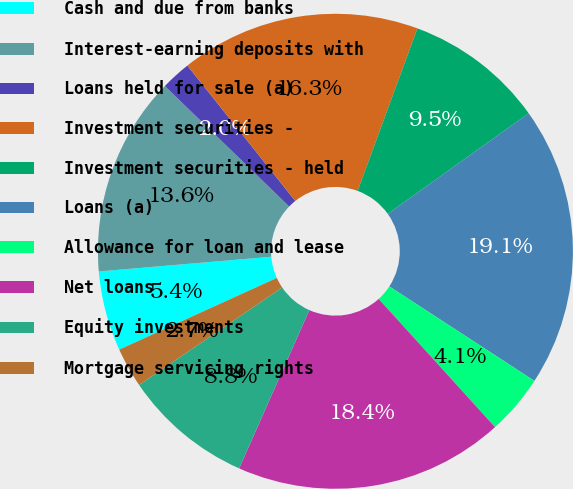<chart> <loc_0><loc_0><loc_500><loc_500><pie_chart><fcel>Cash and due from banks<fcel>Interest-earning deposits with<fcel>Loans held for sale (a)<fcel>Investment securities -<fcel>Investment securities - held<fcel>Loans (a)<fcel>Allowance for loan and lease<fcel>Net loans<fcel>Equity investments<fcel>Mortgage servicing rights<nl><fcel>5.44%<fcel>13.6%<fcel>2.04%<fcel>16.32%<fcel>9.52%<fcel>19.05%<fcel>4.08%<fcel>18.37%<fcel>8.84%<fcel>2.72%<nl></chart> 